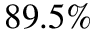Convert formula to latex. <formula><loc_0><loc_0><loc_500><loc_500>8 9 . 5 \%</formula> 